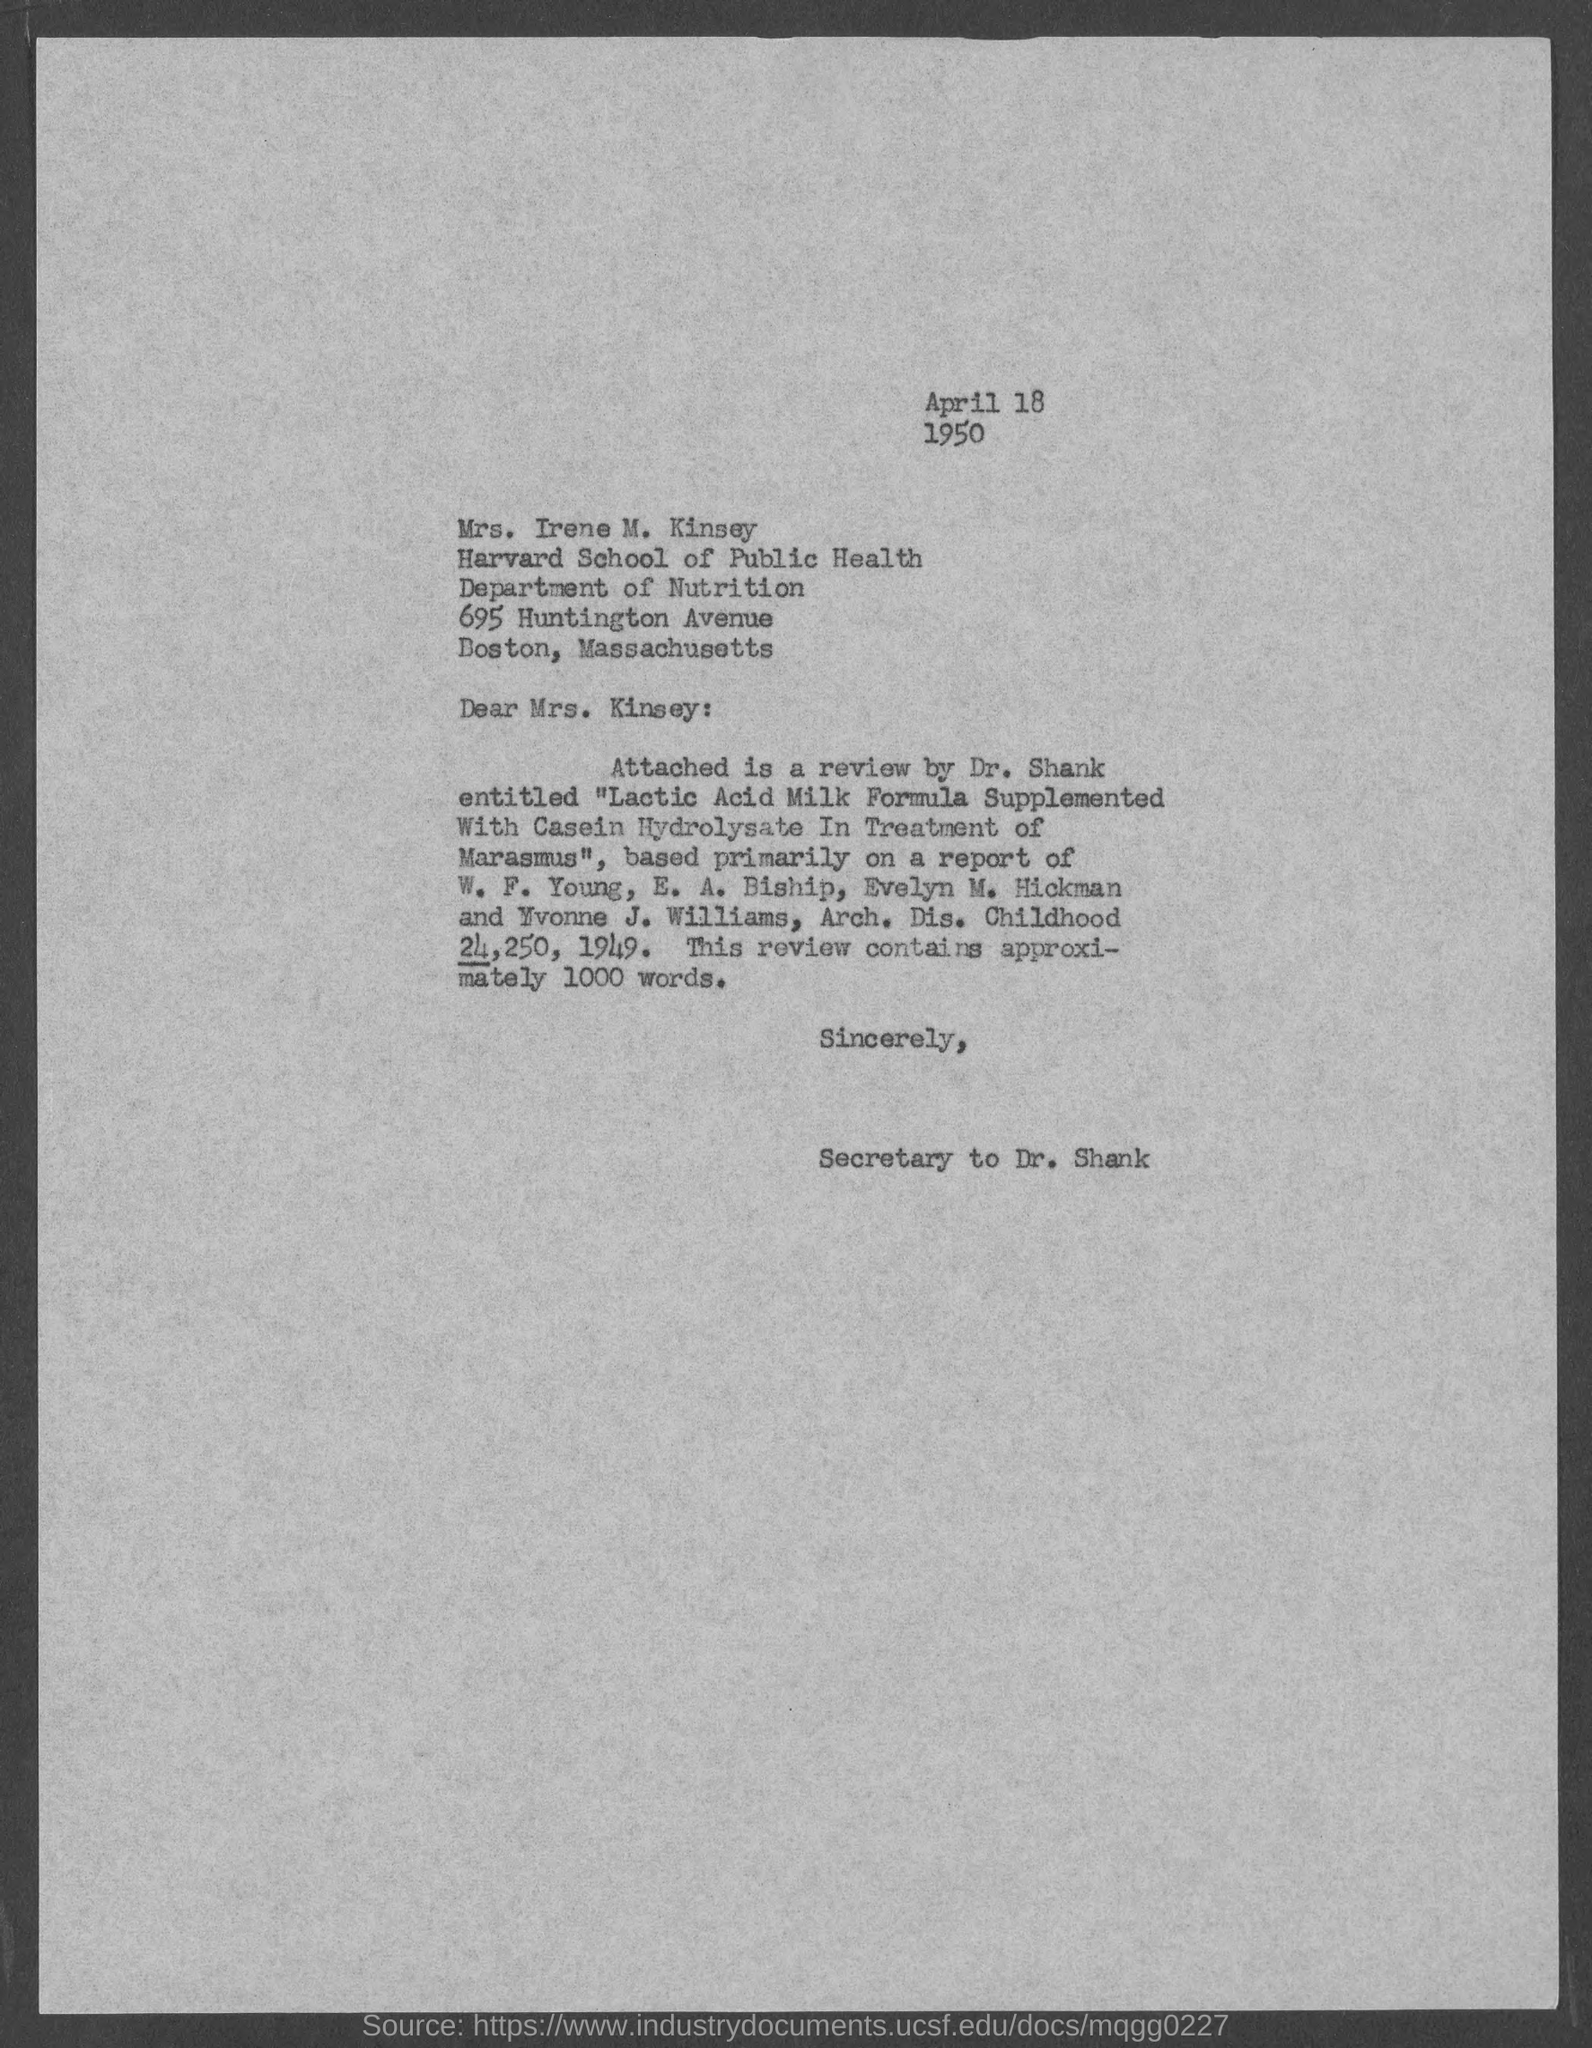Outline some significant characteristics in this image. The salutation of the letter is "Dear Mrs. Kinsey. The date is April 18, 1950. 